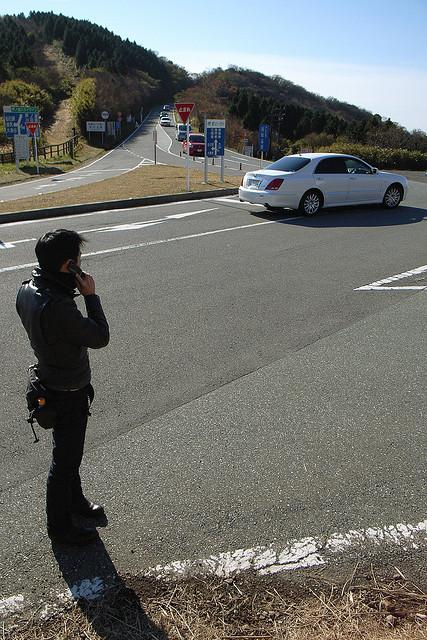What shape is the red sign? Please explain your reasoning. triangular. The shape is a triangle. 